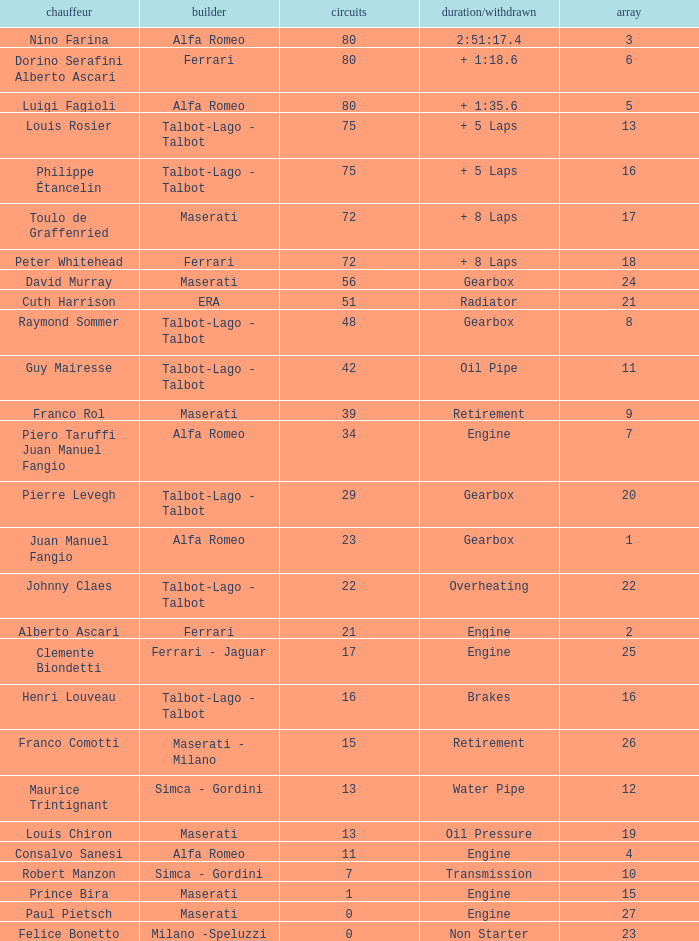What was the smallest grid for Prince bira? 15.0. 